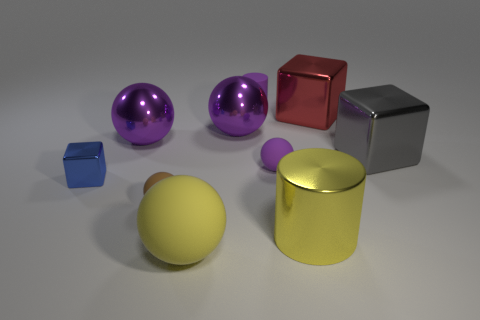Is the purple matte ball the same size as the metallic cylinder?
Provide a short and direct response. No. There is a big sphere in front of the small matte ball that is in front of the small ball that is behind the blue metallic object; what is its material?
Your response must be concise. Rubber. Are there the same number of large metal things that are in front of the blue metallic object and yellow metallic spheres?
Keep it short and to the point. No. What number of things are small metallic things or yellow spheres?
Your answer should be compact. 2. What is the shape of the large yellow thing that is made of the same material as the big red thing?
Your answer should be very brief. Cylinder. What size is the metal object that is in front of the metal cube that is on the left side of the large yellow cylinder?
Offer a very short reply. Large. How many tiny things are yellow metallic objects or cylinders?
Provide a short and direct response. 1. What number of other things are there of the same color as the big rubber ball?
Provide a succinct answer. 1. There is a rubber thing behind the gray thing; does it have the same size as the purple metallic thing that is to the left of the yellow rubber sphere?
Your answer should be compact. No. Do the gray thing and the cube on the left side of the tiny brown matte ball have the same material?
Your response must be concise. Yes. 